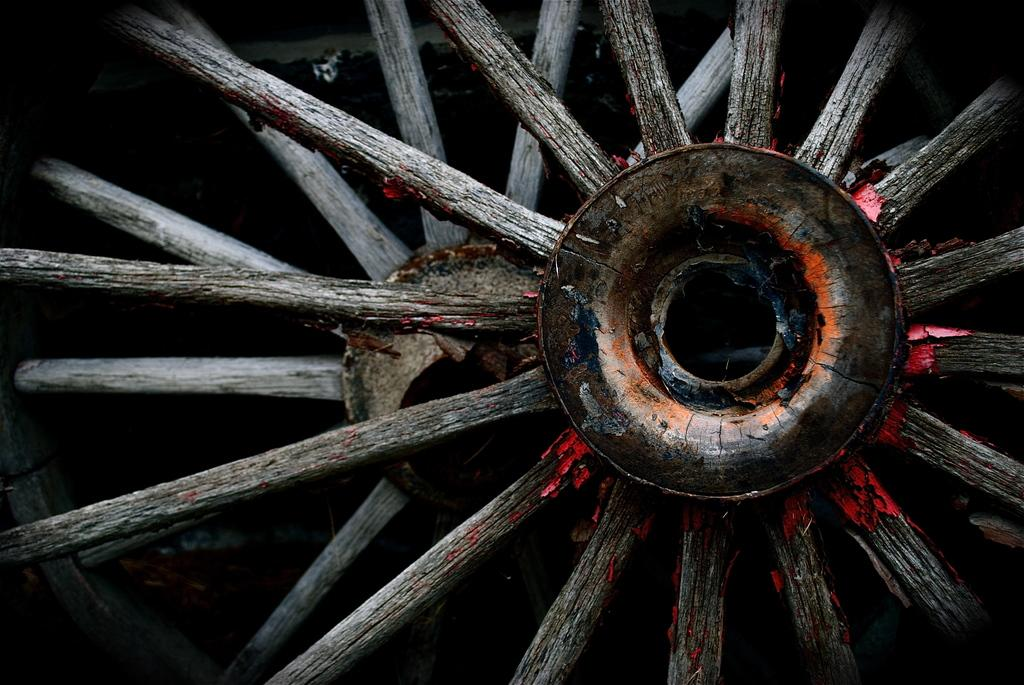What type of object has wheels in the image? The wheels belong to old carts in the image. Can you describe the wheels in more detail? The wheels are part of old carts, which suggests they may be made of wood or metal and have a traditional design. Where is the brother of the person who owns the carts in the image? There is no information about a brother or any people in the image, so it cannot be determined where the brother might be. 